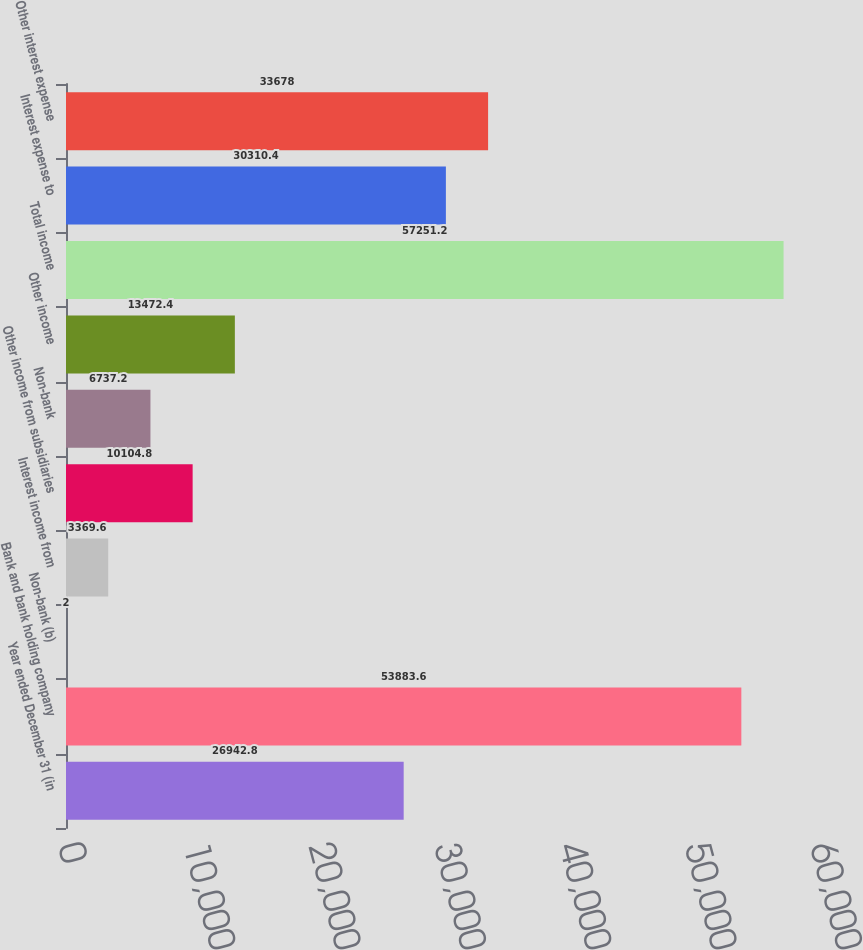<chart> <loc_0><loc_0><loc_500><loc_500><bar_chart><fcel>Year ended December 31 (in<fcel>Bank and bank holding company<fcel>Non-bank (b)<fcel>Interest income from<fcel>Other income from subsidiaries<fcel>Non-bank<fcel>Other income<fcel>Total income<fcel>Interest expense to<fcel>Other interest expense<nl><fcel>26942.8<fcel>53883.6<fcel>2<fcel>3369.6<fcel>10104.8<fcel>6737.2<fcel>13472.4<fcel>57251.2<fcel>30310.4<fcel>33678<nl></chart> 